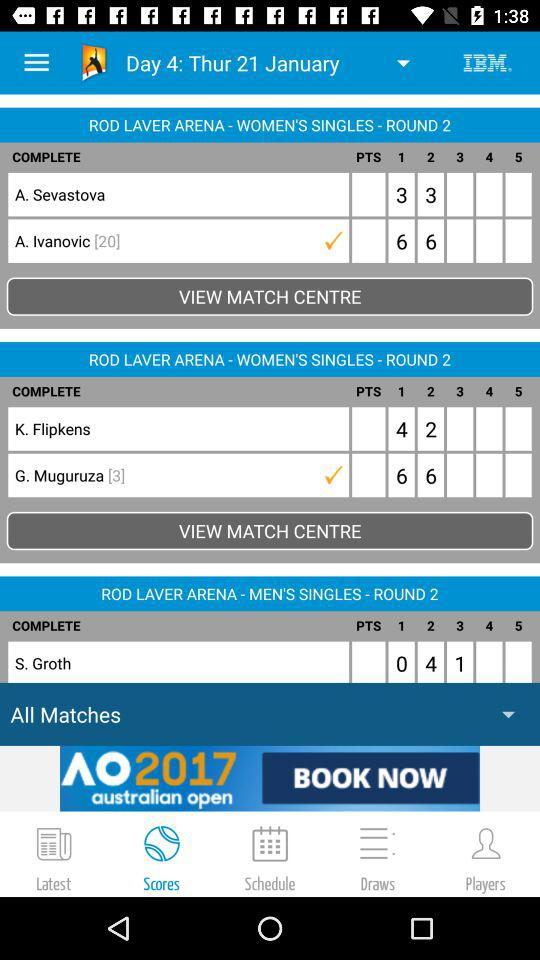How many matches are there in round 2 of the women's singles?
Answer the question using a single word or phrase. 2 